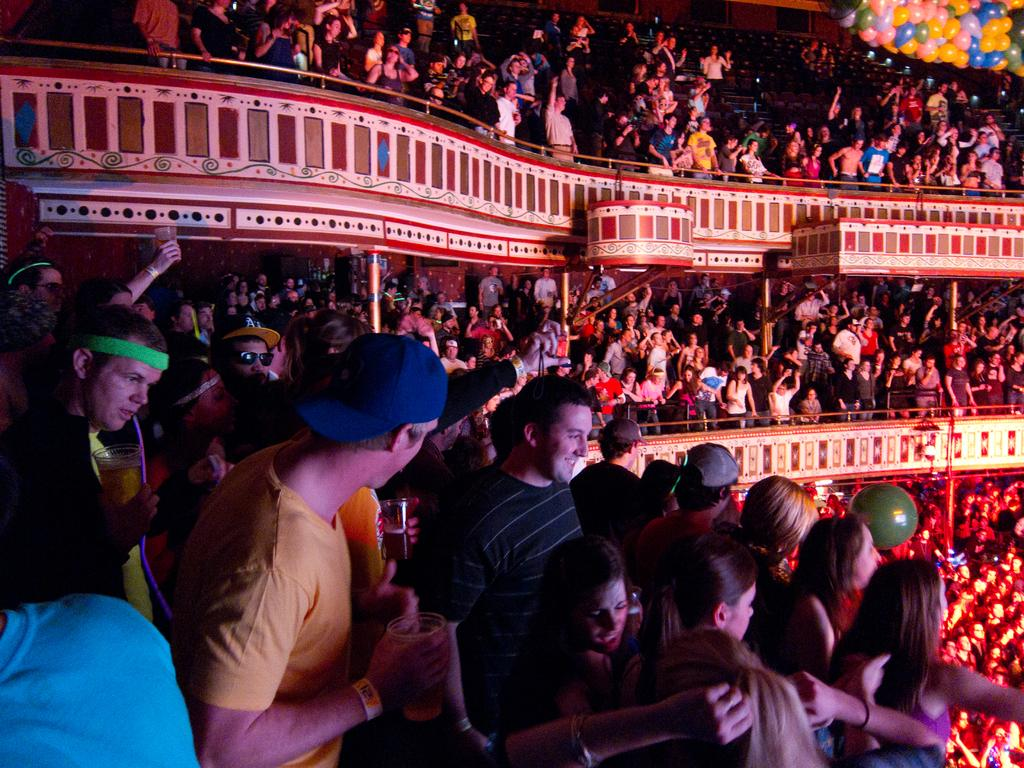What type of location is depicted in the image? The image shows the interior view of a stadium. Can you describe the people in the image? There are a few people in the image. What is one feature of the stadium that can be seen? There is a wall visible in the image. What type of seating is available in the stadium? Some chairs are present in the image. Where are the balloons located in the image? There are balloons in the top right corner of the image. Are there any dogs running on the slope in the image? There are no dogs or slopes present in the image; it shows the interior view of a stadium with chairs, a wall, and balloons. 